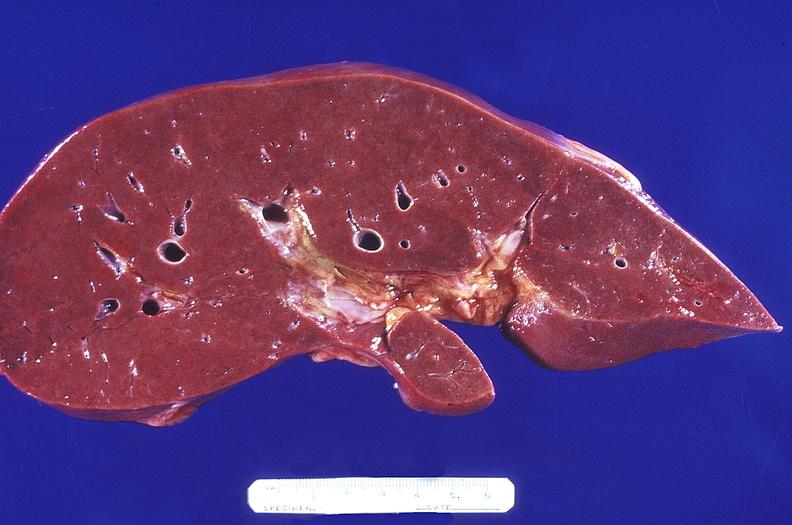what is present?
Answer the question using a single word or phrase. Hepatobiliary 